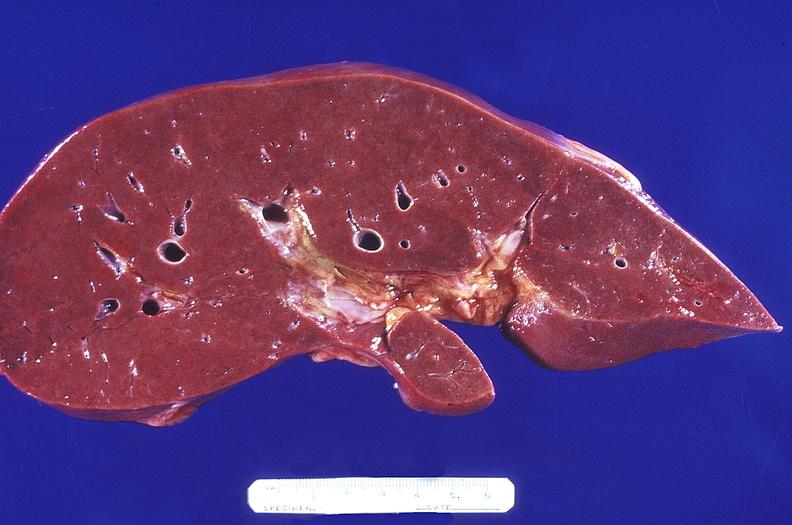what is present?
Answer the question using a single word or phrase. Hepatobiliary 